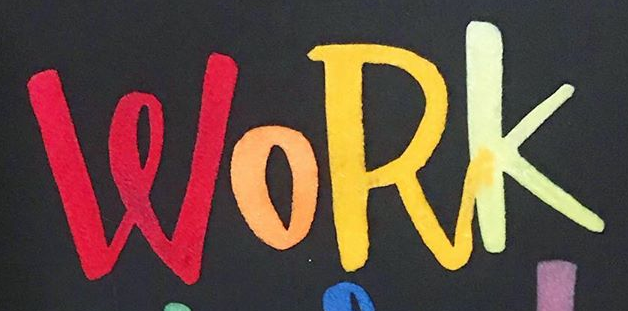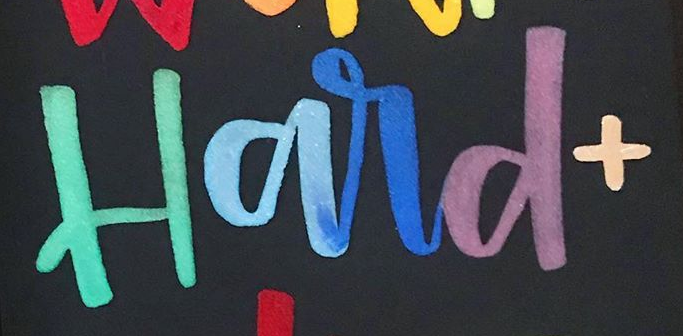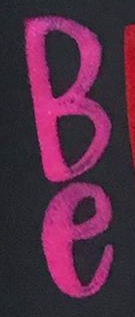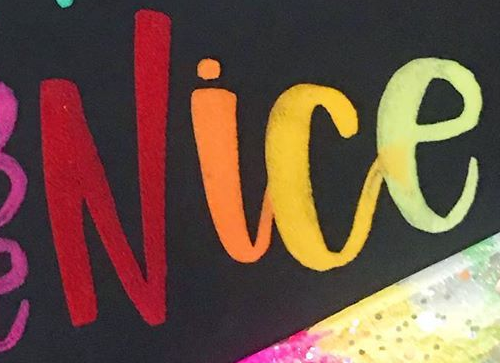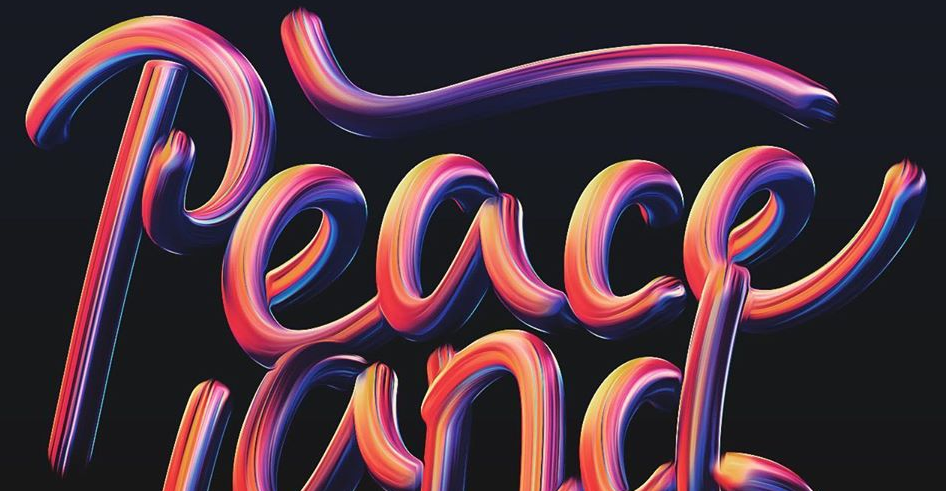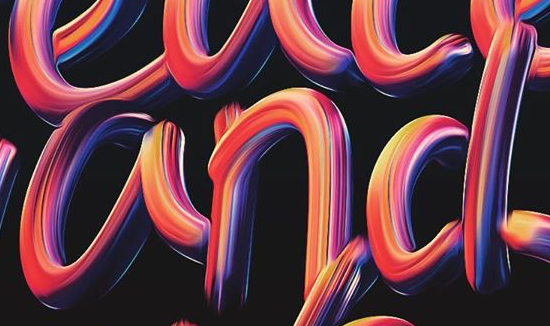Transcribe the words shown in these images in order, separated by a semicolon. WORK; Hard+; Be; Nice; Peace; and 